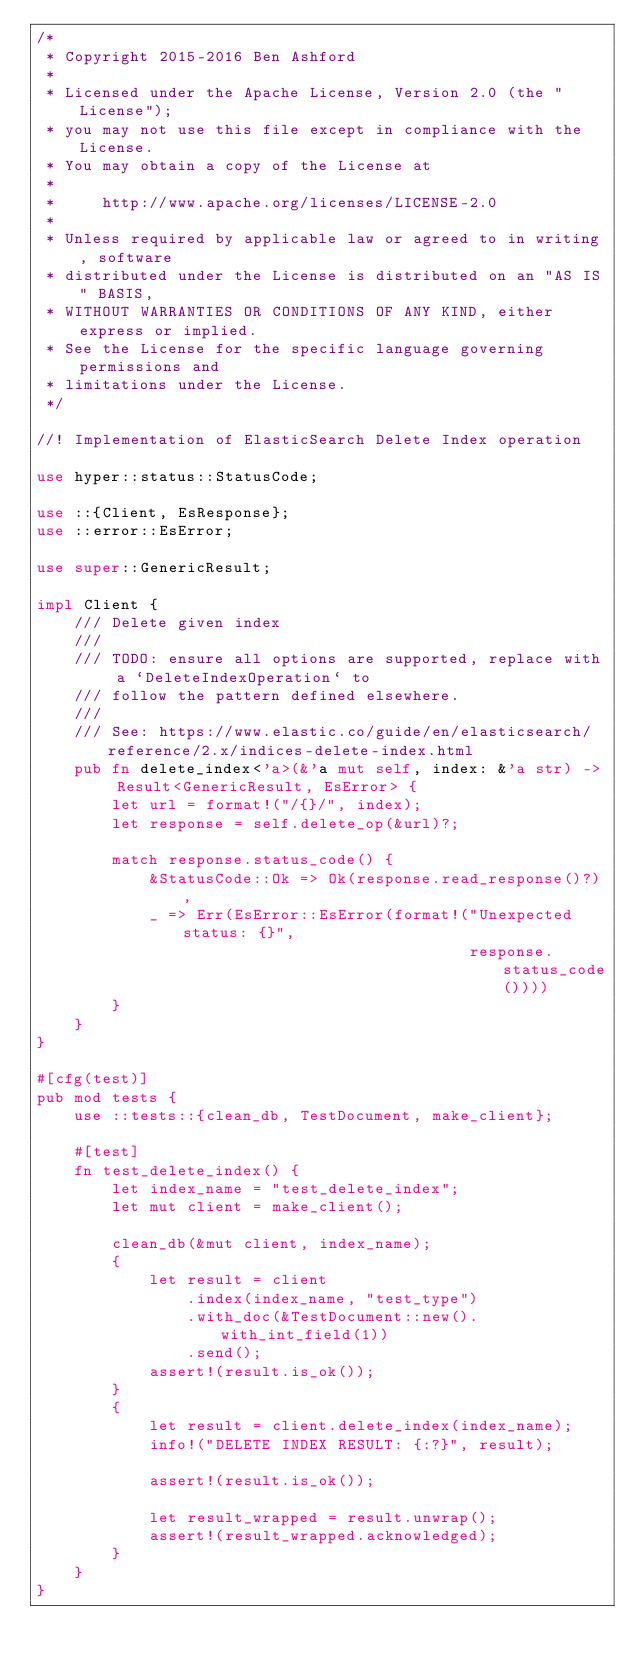<code> <loc_0><loc_0><loc_500><loc_500><_Rust_>/*
 * Copyright 2015-2016 Ben Ashford
 *
 * Licensed under the Apache License, Version 2.0 (the "License");
 * you may not use this file except in compliance with the License.
 * You may obtain a copy of the License at
 *
 *     http://www.apache.org/licenses/LICENSE-2.0
 *
 * Unless required by applicable law or agreed to in writing, software
 * distributed under the License is distributed on an "AS IS" BASIS,
 * WITHOUT WARRANTIES OR CONDITIONS OF ANY KIND, either express or implied.
 * See the License for the specific language governing permissions and
 * limitations under the License.
 */

//! Implementation of ElasticSearch Delete Index operation

use hyper::status::StatusCode;

use ::{Client, EsResponse};
use ::error::EsError;

use super::GenericResult;

impl Client {
    /// Delete given index
    ///
    /// TODO: ensure all options are supported, replace with a `DeleteIndexOperation` to
    /// follow the pattern defined elsewhere.
    ///
    /// See: https://www.elastic.co/guide/en/elasticsearch/reference/2.x/indices-delete-index.html
    pub fn delete_index<'a>(&'a mut self, index: &'a str) -> Result<GenericResult, EsError> {
        let url = format!("/{}/", index);
        let response = self.delete_op(&url)?;

        match response.status_code() {
            &StatusCode::Ok => Ok(response.read_response()?),
            _ => Err(EsError::EsError(format!("Unexpected status: {}",
                                              response.status_code())))
        }
    }
}

#[cfg(test)]
pub mod tests {
    use ::tests::{clean_db, TestDocument, make_client};

    #[test]
    fn test_delete_index() {
        let index_name = "test_delete_index";
        let mut client = make_client();

        clean_db(&mut client, index_name);
        {
            let result = client
                .index(index_name, "test_type")
                .with_doc(&TestDocument::new().with_int_field(1))
                .send();
            assert!(result.is_ok());
        }
        {
            let result = client.delete_index(index_name);
            info!("DELETE INDEX RESULT: {:?}", result);

            assert!(result.is_ok());

            let result_wrapped = result.unwrap();
            assert!(result_wrapped.acknowledged);
        }
    }
}
</code> 